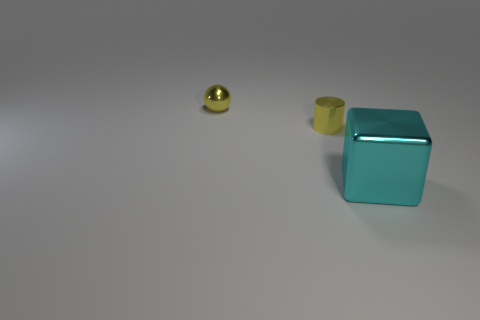What number of shiny objects are in front of the yellow shiny cylinder and behind the metal cube?
Provide a succinct answer. 0. Does the cyan block have the same material as the small yellow thing that is right of the tiny metallic sphere?
Make the answer very short. Yes. What number of cyan objects are either cubes or small metal objects?
Your answer should be very brief. 1. Is there a green rubber thing that has the same size as the cyan thing?
Your answer should be compact. No. What material is the small object that is to the right of the yellow object that is behind the tiny metal thing that is in front of the sphere?
Your response must be concise. Metal. Are there the same number of yellow metal cylinders that are behind the small yellow cylinder and small yellow shiny things?
Make the answer very short. No. Is the yellow thing on the left side of the yellow cylinder made of the same material as the thing in front of the tiny metal cylinder?
Give a very brief answer. Yes. What number of objects are metallic spheres or objects that are to the right of the yellow metallic sphere?
Give a very brief answer. 3. Are there any other large things of the same shape as the large cyan metal object?
Your response must be concise. No. How big is the yellow thing behind the yellow metallic thing that is right of the tiny shiny sphere behind the small yellow cylinder?
Your answer should be very brief. Small. 